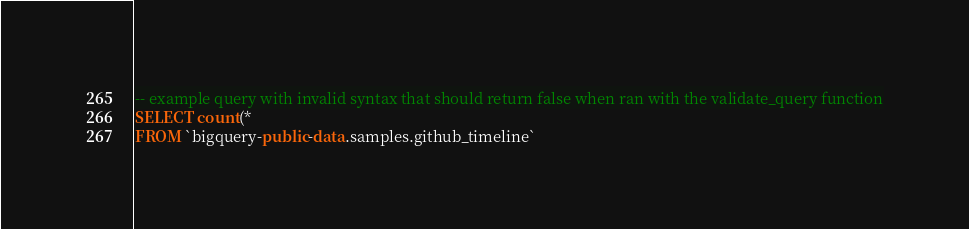Convert code to text. <code><loc_0><loc_0><loc_500><loc_500><_SQL_>-- example query with invalid syntax that should return false when ran with the validate_query function
SELECT count(*
FROM `bigquery-public-data.samples.github_timeline`</code> 